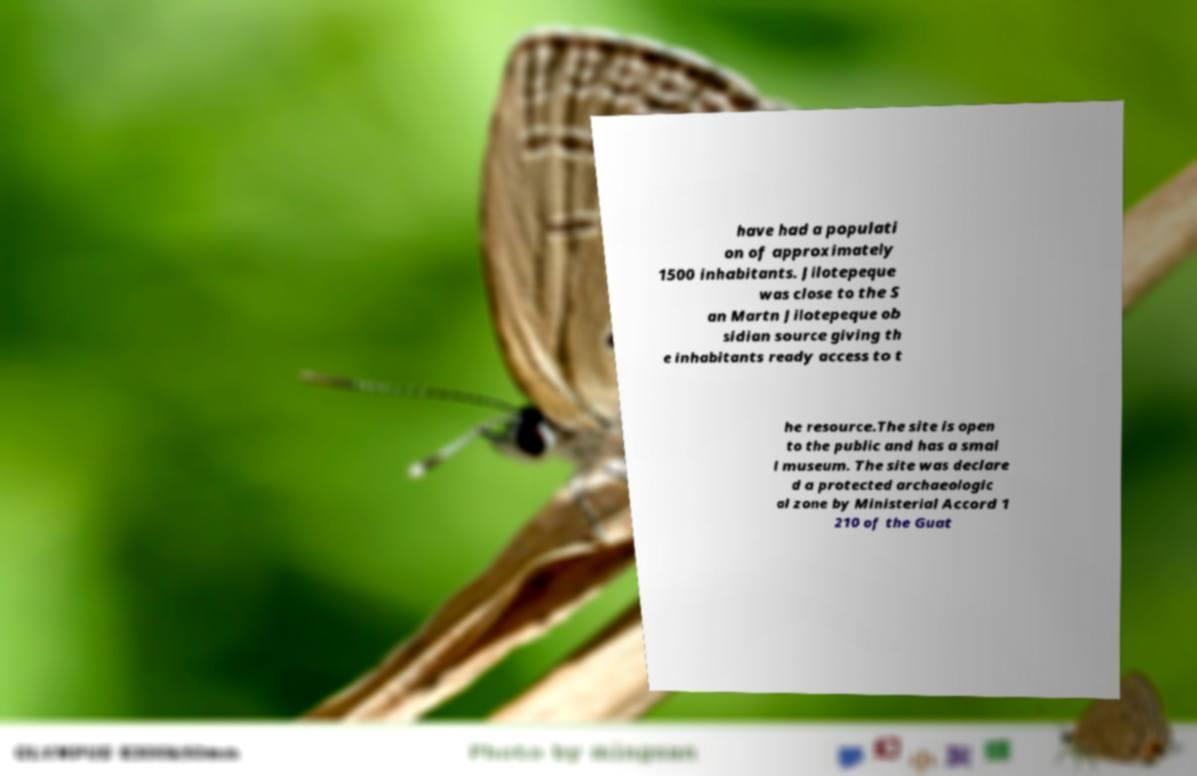I need the written content from this picture converted into text. Can you do that? have had a populati on of approximately 1500 inhabitants. Jilotepeque was close to the S an Martn Jilotepeque ob sidian source giving th e inhabitants ready access to t he resource.The site is open to the public and has a smal l museum. The site was declare d a protected archaeologic al zone by Ministerial Accord 1 210 of the Guat 